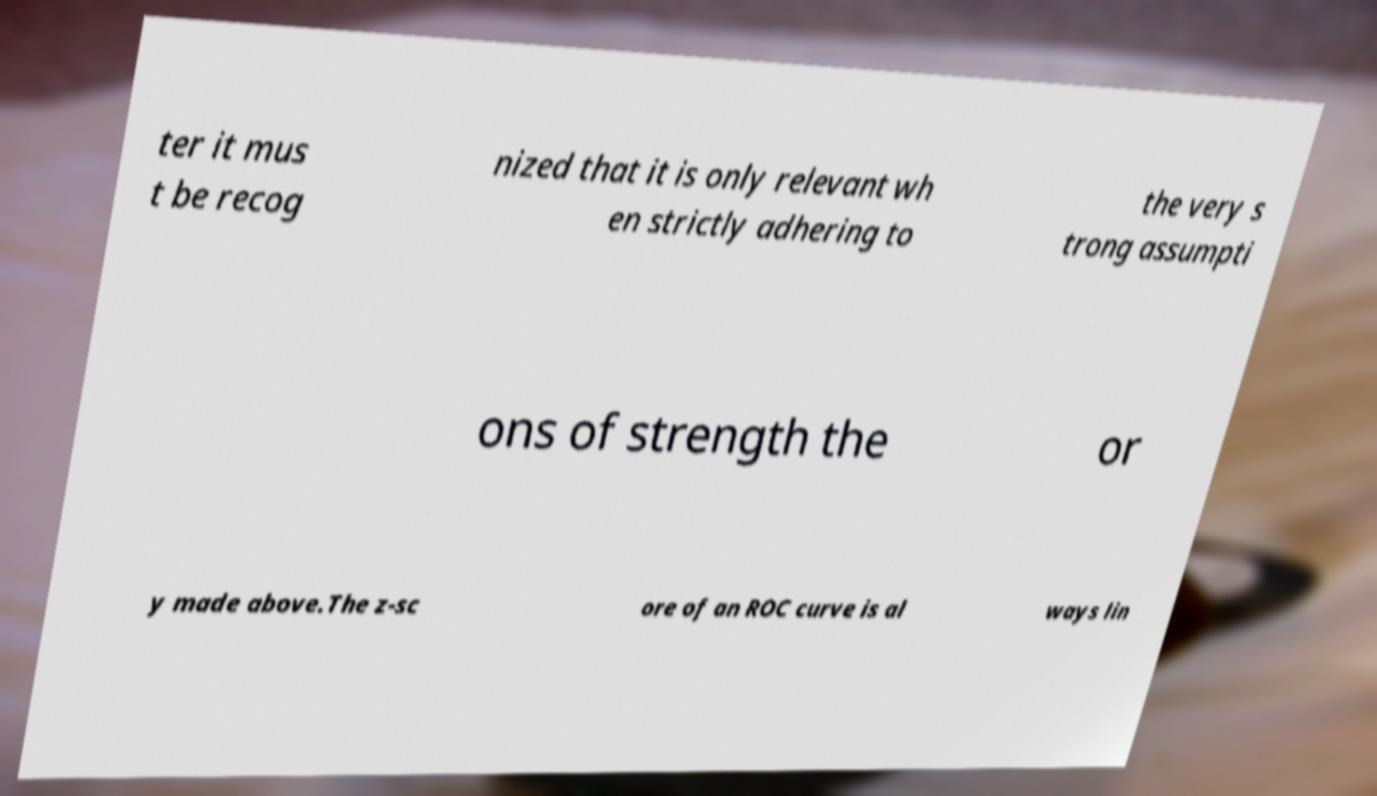Please read and relay the text visible in this image. What does it say? ter it mus t be recog nized that it is only relevant wh en strictly adhering to the very s trong assumpti ons of strength the or y made above.The z-sc ore of an ROC curve is al ways lin 